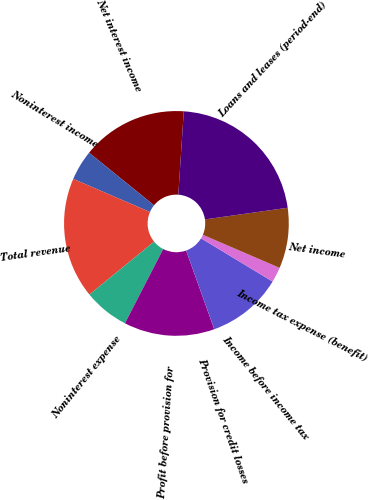Convert chart. <chart><loc_0><loc_0><loc_500><loc_500><pie_chart><fcel>Net interest income<fcel>Noninterest income<fcel>Total revenue<fcel>Noninterest expense<fcel>Profit before provision for<fcel>Provision for credit losses<fcel>Income before income tax<fcel>Income tax expense (benefit)<fcel>Net income<fcel>Loans and leases (period-end)<nl><fcel>15.21%<fcel>4.35%<fcel>17.39%<fcel>6.52%<fcel>13.04%<fcel>0.01%<fcel>10.87%<fcel>2.18%<fcel>8.7%<fcel>21.73%<nl></chart> 